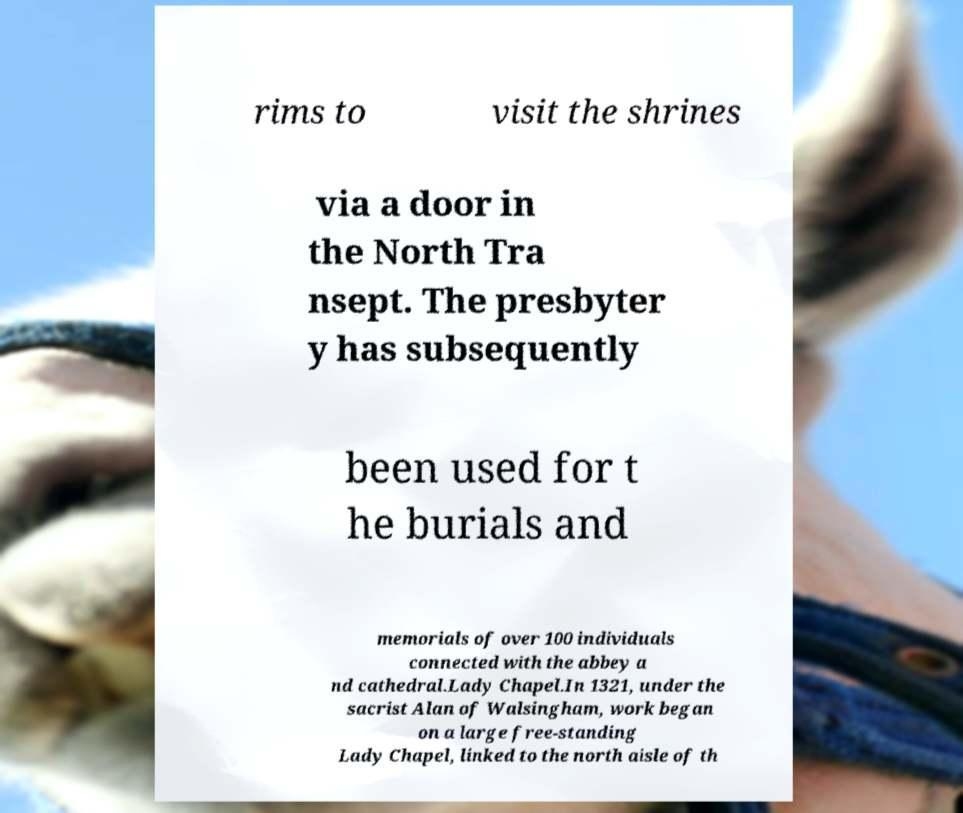There's text embedded in this image that I need extracted. Can you transcribe it verbatim? rims to visit the shrines via a door in the North Tra nsept. The presbyter y has subsequently been used for t he burials and memorials of over 100 individuals connected with the abbey a nd cathedral.Lady Chapel.In 1321, under the sacrist Alan of Walsingham, work began on a large free-standing Lady Chapel, linked to the north aisle of th 